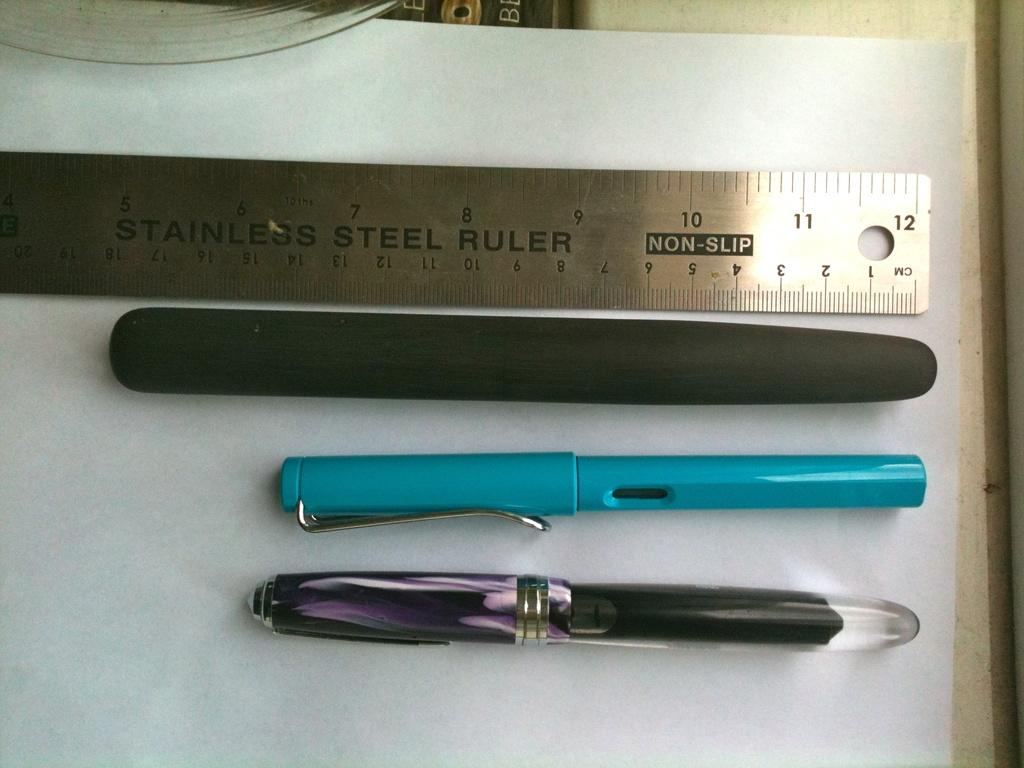What stationery items can be seen in the image? There are pens in the image. What device is used for measuring weight in the image? There is a scale in the image. What type of paper is present in the image? There is a white color paper in the image. What is the arrangement of objects in the image? There are other objects on an object in the image. What information is displayed on the scale? Something is written on the scale. What book is the person reading in the image? There is no person or book present in the image. How does the mind of the person in the image appear? There is no person or indication of a mind in the image. 